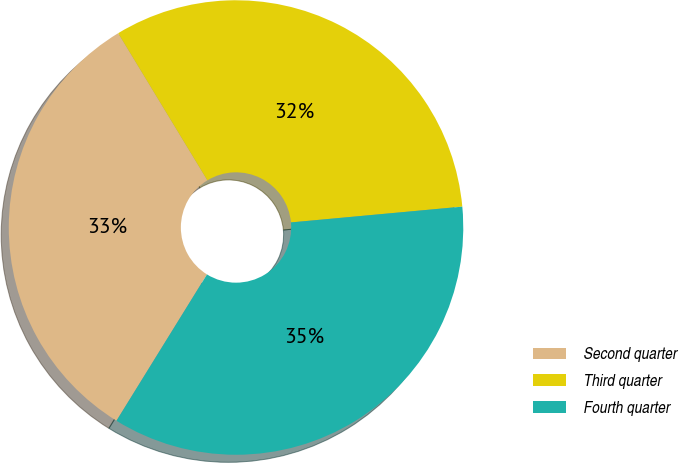<chart> <loc_0><loc_0><loc_500><loc_500><pie_chart><fcel>Second quarter<fcel>Third quarter<fcel>Fourth quarter<nl><fcel>32.51%<fcel>32.21%<fcel>35.28%<nl></chart> 